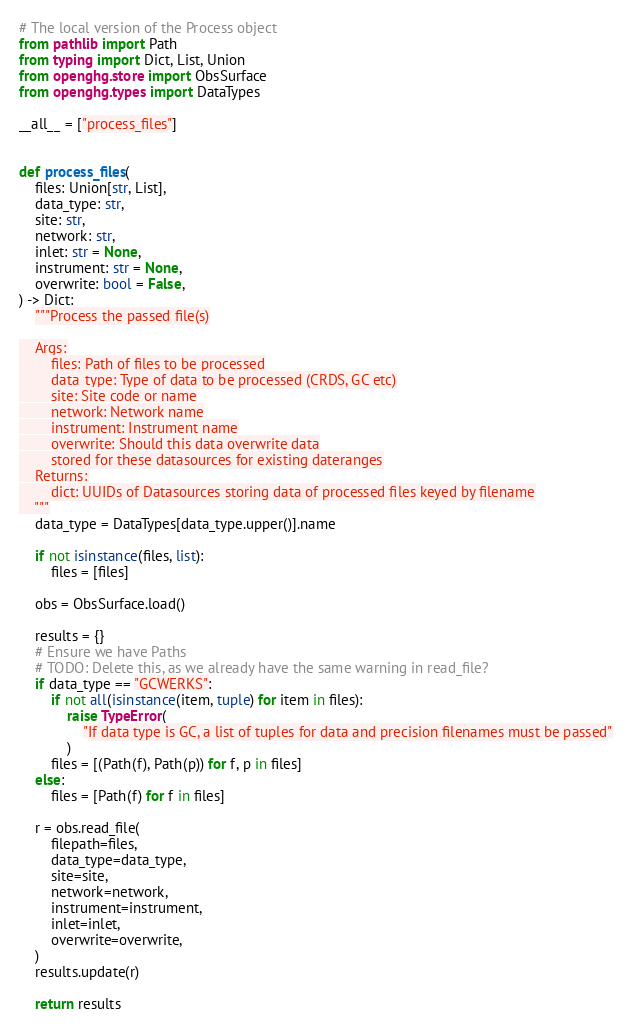Convert code to text. <code><loc_0><loc_0><loc_500><loc_500><_Python_># The local version of the Process object
from pathlib import Path
from typing import Dict, List, Union
from openghg.store import ObsSurface
from openghg.types import DataTypes

__all__ = ["process_files"]


def process_files(
    files: Union[str, List],
    data_type: str,
    site: str,
    network: str,
    inlet: str = None,
    instrument: str = None,
    overwrite: bool = False,
) -> Dict:
    """Process the passed file(s)

    Args:
        files: Path of files to be processed
        data_type: Type of data to be processed (CRDS, GC etc)
        site: Site code or name
        network: Network name
        instrument: Instrument name
        overwrite: Should this data overwrite data
        stored for these datasources for existing dateranges
    Returns:
        dict: UUIDs of Datasources storing data of processed files keyed by filename
    """
    data_type = DataTypes[data_type.upper()].name

    if not isinstance(files, list):
        files = [files]

    obs = ObsSurface.load()

    results = {}
    # Ensure we have Paths
    # TODO: Delete this, as we already have the same warning in read_file?
    if data_type == "GCWERKS":
        if not all(isinstance(item, tuple) for item in files):
            raise TypeError(
                "If data type is GC, a list of tuples for data and precision filenames must be passed"
            )
        files = [(Path(f), Path(p)) for f, p in files]
    else:
        files = [Path(f) for f in files]

    r = obs.read_file(
        filepath=files,
        data_type=data_type,
        site=site,
        network=network,
        instrument=instrument,
        inlet=inlet,
        overwrite=overwrite,
    )
    results.update(r)

    return results
</code> 